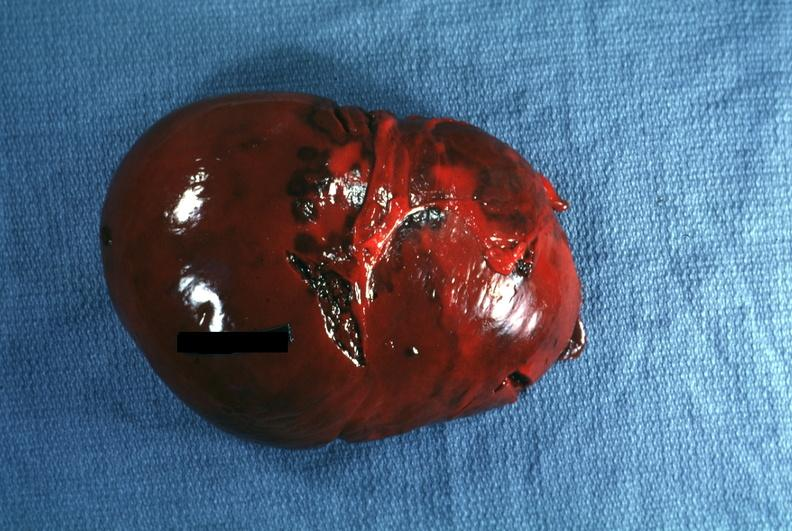what easily seen?
Answer the question using a single word or phrase. External view several capsule lacerations 